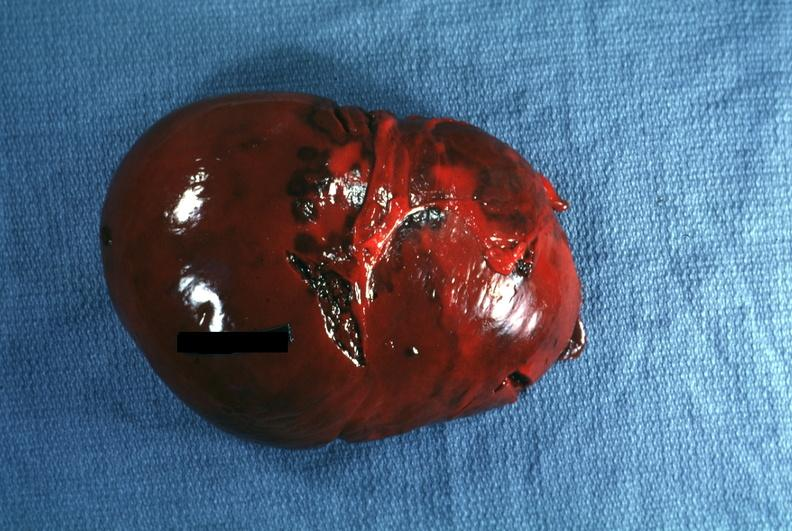what easily seen?
Answer the question using a single word or phrase. External view several capsule lacerations 